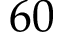Convert formula to latex. <formula><loc_0><loc_0><loc_500><loc_500>6 0</formula> 